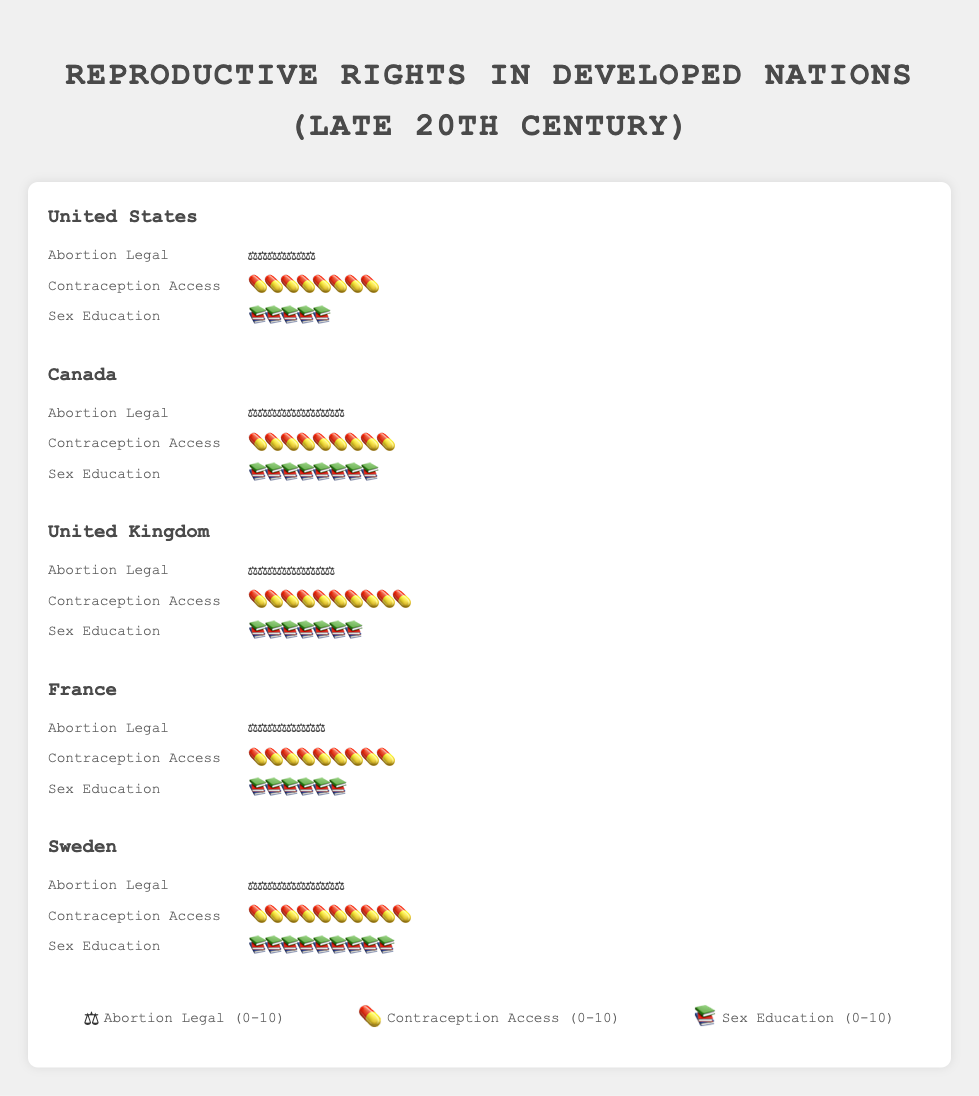Which country has the highest score for "Abortion Legal"? Sweden and Canada both have the highest score of 10 icons, indicating the highest rating for the legality and accessibility of abortion.
Answer: Sweden, Canada Compare the "Contraception Access" scores of the United Kingdom and France. The United Kingdom has 10 icons while France has 9 icons for "Contraception Access." Analyzing the figure shows the comparison easily.
Answer: UK: 10, France: 9 Which country has the lowest score for "Sex Education"? The United States has the lowest score for "Sex Education" with only 5 icons, based on the icons' count for each country.
Answer: United States What is the average score for "Abortion Legal" among all listed countries? Adding the "Abortion Legal" scores: 7 (US) + 10 (Canada) + 9 (UK) + 8 (France) + 10 (Sweden) = 44. Dividing by the total number of countries (5), the average is 44/5 = 8.8
Answer: 8.8 Which country shows equal ratings for "Contraception Access" and "Sex Education"? Sweden has equal ratings for both "Contraception Access" and "Sex Education," each with 10 icons. By comparing the number of icons for each metric, Sweden is the country where both metrics have equal high rating.
Answer: Sweden How many more "Sex Education" icons does Sweden have compared to the United States? Sweden has 9 "Sex Education" icons, while the United States has 5. Subtracting these values, 9 - 5 = 4.
Answer: 4 If you sum up the "Abortion Legal" scores for the United Kingdom and France, what is the total? The United Kingdom has 9 icons and France has 8 icons for "Abortion Legal." Summing these values gives 9 + 8 = 17.
Answer: 17 